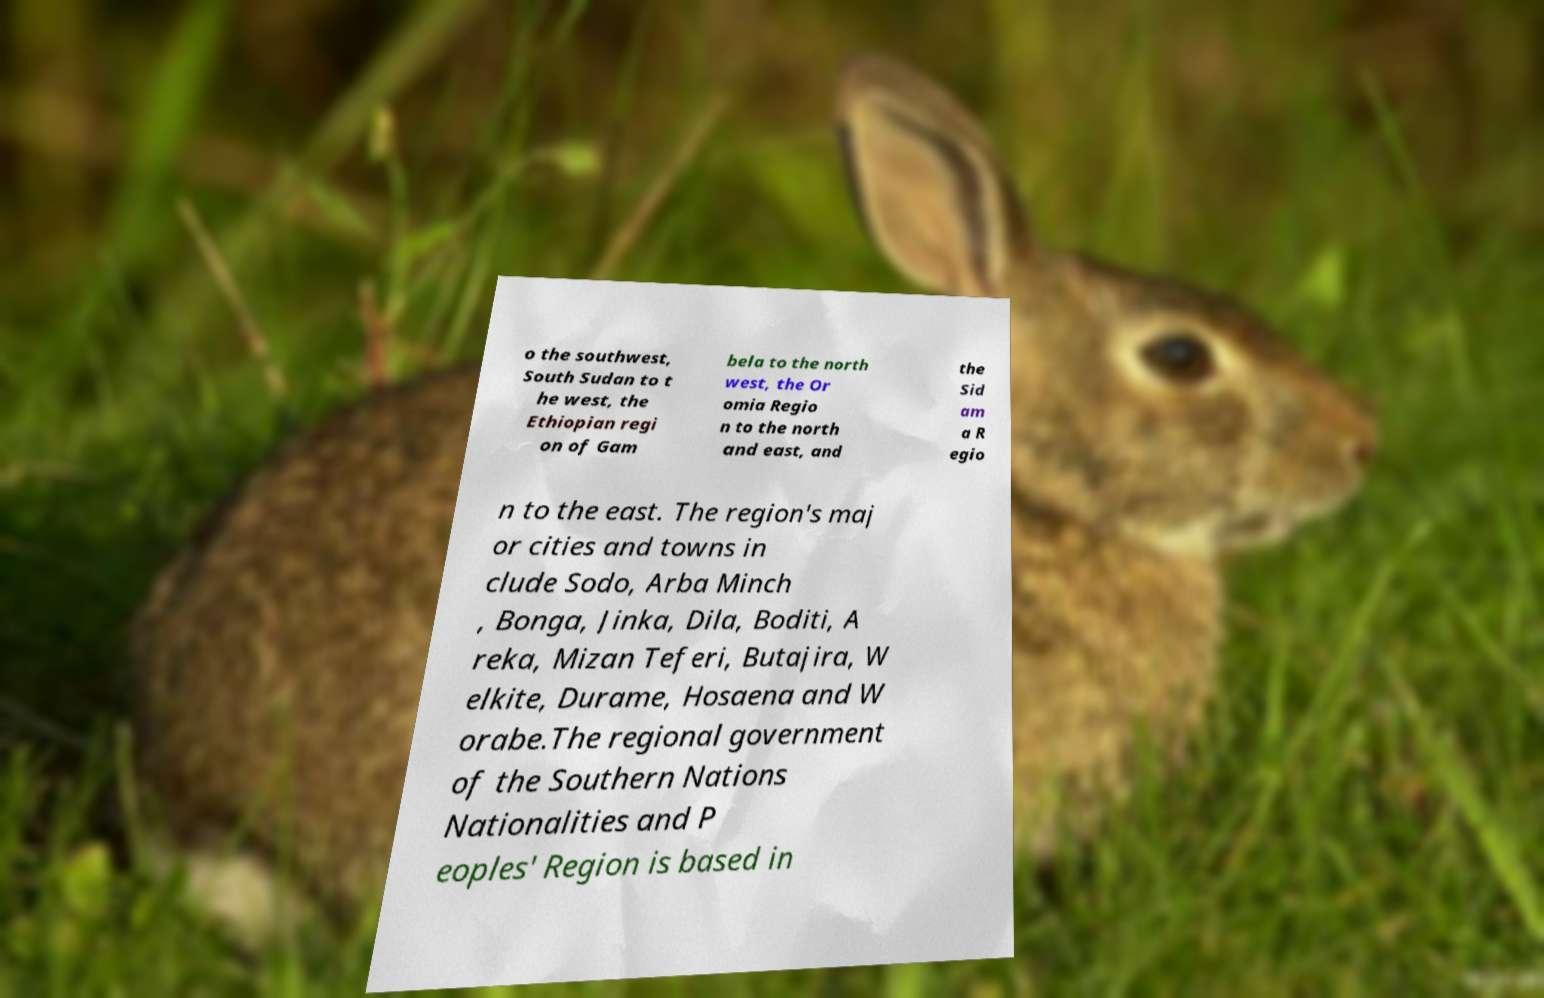I need the written content from this picture converted into text. Can you do that? o the southwest, South Sudan to t he west, the Ethiopian regi on of Gam bela to the north west, the Or omia Regio n to the north and east, and the Sid am a R egio n to the east. The region's maj or cities and towns in clude Sodo, Arba Minch , Bonga, Jinka, Dila, Boditi, A reka, Mizan Teferi, Butajira, W elkite, Durame, Hosaena and W orabe.The regional government of the Southern Nations Nationalities and P eoples' Region is based in 